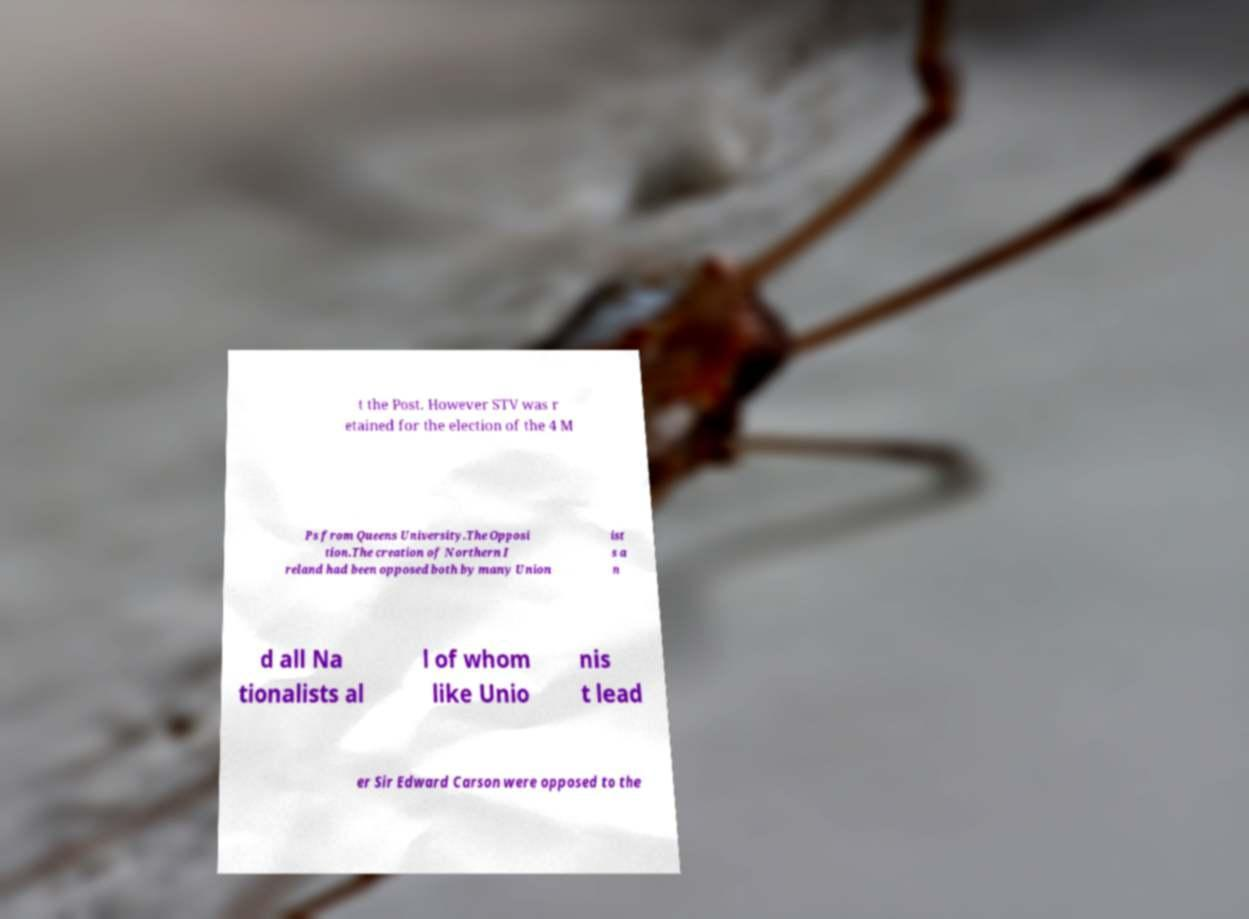Could you assist in decoding the text presented in this image and type it out clearly? t the Post. However STV was r etained for the election of the 4 M Ps from Queens University.The Opposi tion.The creation of Northern I reland had been opposed both by many Union ist s a n d all Na tionalists al l of whom like Unio nis t lead er Sir Edward Carson were opposed to the 